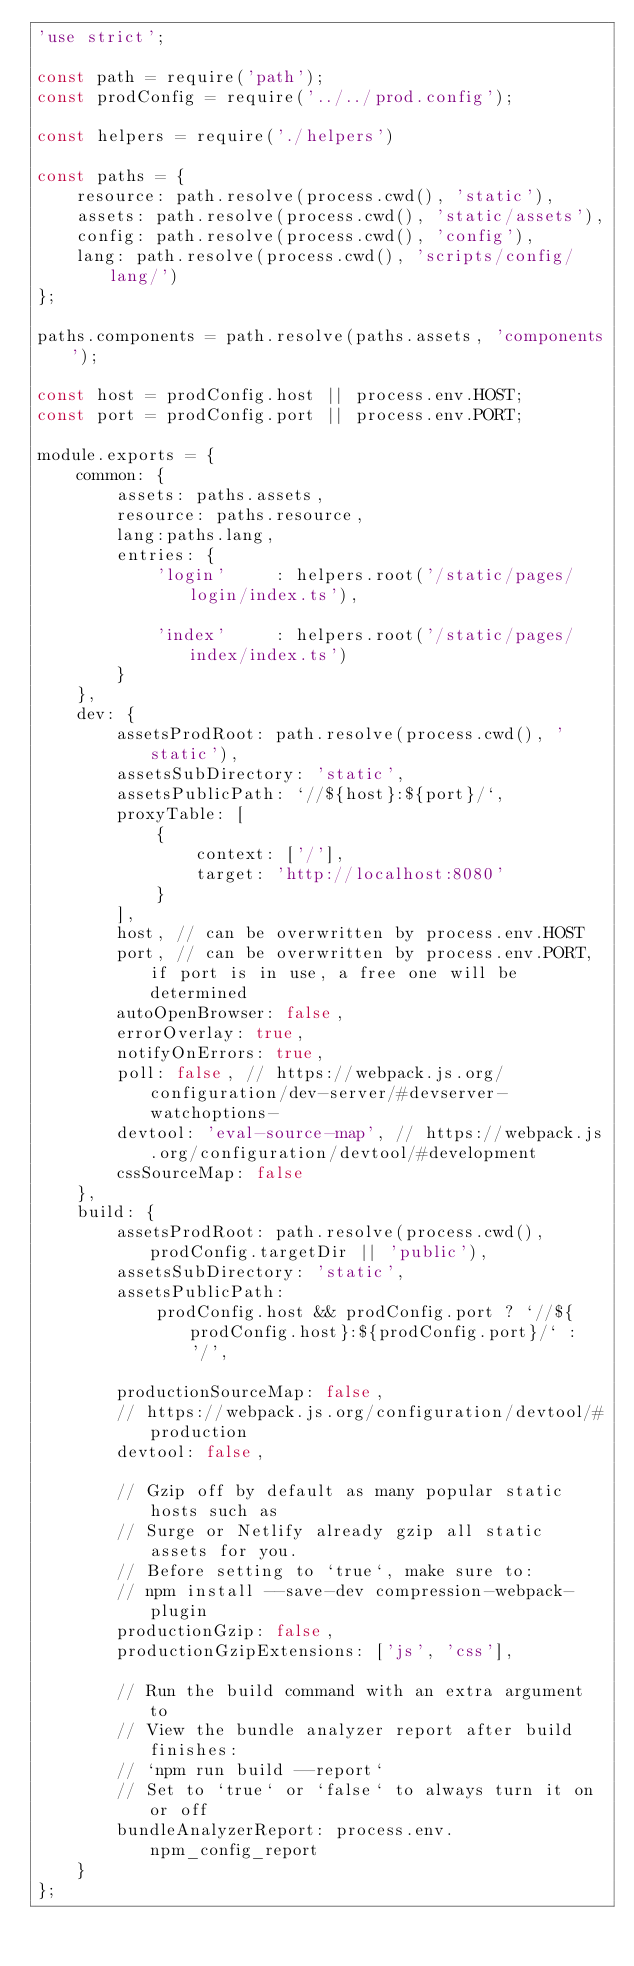Convert code to text. <code><loc_0><loc_0><loc_500><loc_500><_JavaScript_>'use strict';

const path = require('path');
const prodConfig = require('../../prod.config');

const helpers = require('./helpers')

const paths = {
    resource: path.resolve(process.cwd(), 'static'),
    assets: path.resolve(process.cwd(), 'static/assets'),
    config: path.resolve(process.cwd(), 'config'),
    lang: path.resolve(process.cwd(), 'scripts/config/lang/')
};

paths.components = path.resolve(paths.assets, 'components');

const host = prodConfig.host || process.env.HOST;
const port = prodConfig.port || process.env.PORT;

module.exports = {
    common: {
        assets: paths.assets,
        resource: paths.resource,
        lang:paths.lang,
        entries: {
            'login'     : helpers.root('/static/pages/login/index.ts'),

            'index'     : helpers.root('/static/pages/index/index.ts')
        }
    },
    dev: {
        assetsProdRoot: path.resolve(process.cwd(), 'static'),
        assetsSubDirectory: 'static',
        assetsPublicPath: `//${host}:${port}/`,
        proxyTable: [
            {
                context: ['/'],
                target: 'http://localhost:8080'
            }
        ],
        host, // can be overwritten by process.env.HOST
        port, // can be overwritten by process.env.PORT, if port is in use, a free one will be determined
        autoOpenBrowser: false,
        errorOverlay: true,
        notifyOnErrors: true,
        poll: false, // https://webpack.js.org/configuration/dev-server/#devserver-watchoptions-
        devtool: 'eval-source-map', // https://webpack.js.org/configuration/devtool/#development
        cssSourceMap: false
    },
    build: {
        assetsProdRoot: path.resolve(process.cwd(), prodConfig.targetDir || 'public'),
        assetsSubDirectory: 'static',
        assetsPublicPath:
            prodConfig.host && prodConfig.port ? `//${prodConfig.host}:${prodConfig.port}/` : '/',

        productionSourceMap: false,
        // https://webpack.js.org/configuration/devtool/#production
        devtool: false,

        // Gzip off by default as many popular static hosts such as
        // Surge or Netlify already gzip all static assets for you.
        // Before setting to `true`, make sure to:
        // npm install --save-dev compression-webpack-plugin
        productionGzip: false,
        productionGzipExtensions: ['js', 'css'],

        // Run the build command with an extra argument to
        // View the bundle analyzer report after build finishes:
        // `npm run build --report`
        // Set to `true` or `false` to always turn it on or off
        bundleAnalyzerReport: process.env.npm_config_report
    }
};
</code> 